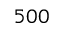Convert formula to latex. <formula><loc_0><loc_0><loc_500><loc_500>5 0 0</formula> 